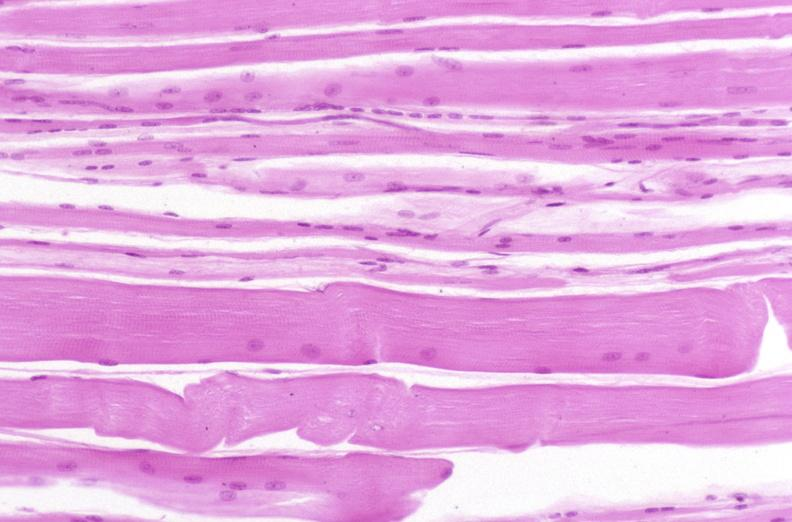s musculoskeletal present?
Answer the question using a single word or phrase. Yes 